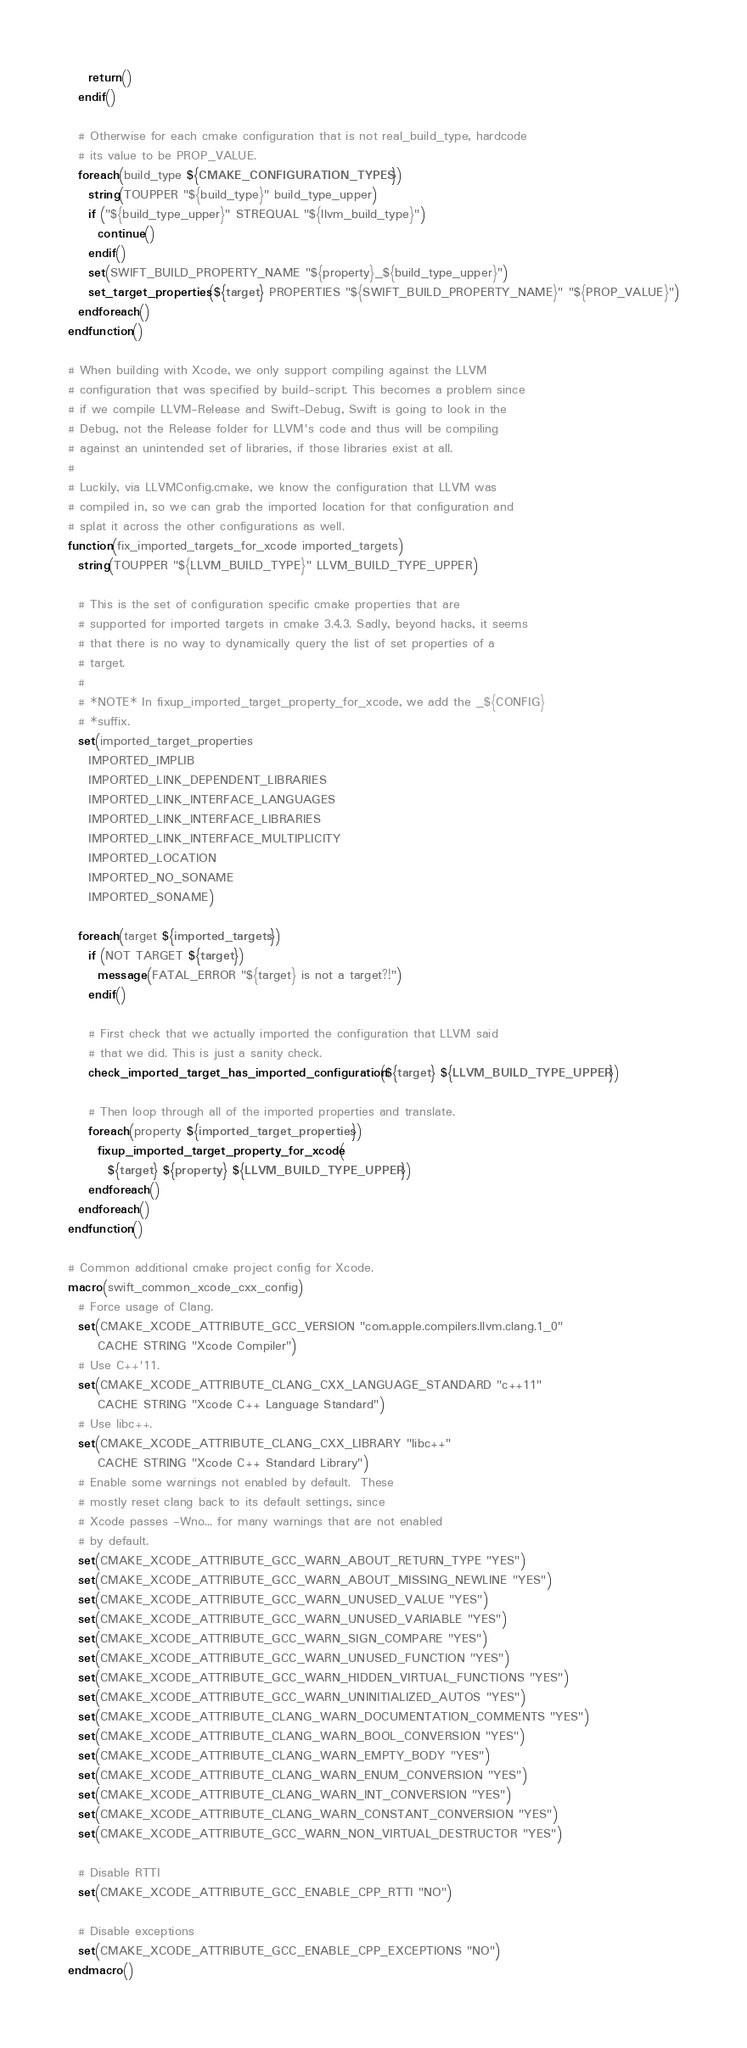Convert code to text. <code><loc_0><loc_0><loc_500><loc_500><_CMake_>    return()
  endif()

  # Otherwise for each cmake configuration that is not real_build_type, hardcode
  # its value to be PROP_VALUE.
  foreach(build_type ${CMAKE_CONFIGURATION_TYPES})
    string(TOUPPER "${build_type}" build_type_upper)
    if ("${build_type_upper}" STREQUAL "${llvm_build_type}")
      continue()
    endif()
    set(SWIFT_BUILD_PROPERTY_NAME "${property}_${build_type_upper}")
    set_target_properties(${target} PROPERTIES "${SWIFT_BUILD_PROPERTY_NAME}" "${PROP_VALUE}")
  endforeach()
endfunction()

# When building with Xcode, we only support compiling against the LLVM
# configuration that was specified by build-script. This becomes a problem since
# if we compile LLVM-Release and Swift-Debug, Swift is going to look in the
# Debug, not the Release folder for LLVM's code and thus will be compiling
# against an unintended set of libraries, if those libraries exist at all.
#
# Luckily, via LLVMConfig.cmake, we know the configuration that LLVM was
# compiled in, so we can grab the imported location for that configuration and
# splat it across the other configurations as well.
function(fix_imported_targets_for_xcode imported_targets)
  string(TOUPPER "${LLVM_BUILD_TYPE}" LLVM_BUILD_TYPE_UPPER)

  # This is the set of configuration specific cmake properties that are
  # supported for imported targets in cmake 3.4.3. Sadly, beyond hacks, it seems
  # that there is no way to dynamically query the list of set properties of a
  # target.
  #
  # *NOTE* In fixup_imported_target_property_for_xcode, we add the _${CONFIG}
  # *suffix.
  set(imported_target_properties
    IMPORTED_IMPLIB
    IMPORTED_LINK_DEPENDENT_LIBRARIES
    IMPORTED_LINK_INTERFACE_LANGUAGES
    IMPORTED_LINK_INTERFACE_LIBRARIES
    IMPORTED_LINK_INTERFACE_MULTIPLICITY
    IMPORTED_LOCATION
    IMPORTED_NO_SONAME
    IMPORTED_SONAME)

  foreach(target ${imported_targets})
    if (NOT TARGET ${target})
      message(FATAL_ERROR "${target} is not a target?!")
    endif()

    # First check that we actually imported the configuration that LLVM said
    # that we did. This is just a sanity check.
    check_imported_target_has_imported_configuration(${target} ${LLVM_BUILD_TYPE_UPPER})

    # Then loop through all of the imported properties and translate.
    foreach(property ${imported_target_properties})
      fixup_imported_target_property_for_xcode(
        ${target} ${property} ${LLVM_BUILD_TYPE_UPPER})
    endforeach()
  endforeach()
endfunction()

# Common additional cmake project config for Xcode.
macro(swift_common_xcode_cxx_config)
  # Force usage of Clang.
  set(CMAKE_XCODE_ATTRIBUTE_GCC_VERSION "com.apple.compilers.llvm.clang.1_0"
      CACHE STRING "Xcode Compiler")
  # Use C++'11.
  set(CMAKE_XCODE_ATTRIBUTE_CLANG_CXX_LANGUAGE_STANDARD "c++11"
      CACHE STRING "Xcode C++ Language Standard")
  # Use libc++.
  set(CMAKE_XCODE_ATTRIBUTE_CLANG_CXX_LIBRARY "libc++"
      CACHE STRING "Xcode C++ Standard Library")
  # Enable some warnings not enabled by default.  These
  # mostly reset clang back to its default settings, since
  # Xcode passes -Wno... for many warnings that are not enabled
  # by default.
  set(CMAKE_XCODE_ATTRIBUTE_GCC_WARN_ABOUT_RETURN_TYPE "YES")
  set(CMAKE_XCODE_ATTRIBUTE_GCC_WARN_ABOUT_MISSING_NEWLINE "YES")
  set(CMAKE_XCODE_ATTRIBUTE_GCC_WARN_UNUSED_VALUE "YES")
  set(CMAKE_XCODE_ATTRIBUTE_GCC_WARN_UNUSED_VARIABLE "YES")
  set(CMAKE_XCODE_ATTRIBUTE_GCC_WARN_SIGN_COMPARE "YES")
  set(CMAKE_XCODE_ATTRIBUTE_GCC_WARN_UNUSED_FUNCTION "YES")
  set(CMAKE_XCODE_ATTRIBUTE_GCC_WARN_HIDDEN_VIRTUAL_FUNCTIONS "YES")
  set(CMAKE_XCODE_ATTRIBUTE_GCC_WARN_UNINITIALIZED_AUTOS "YES")
  set(CMAKE_XCODE_ATTRIBUTE_CLANG_WARN_DOCUMENTATION_COMMENTS "YES")
  set(CMAKE_XCODE_ATTRIBUTE_CLANG_WARN_BOOL_CONVERSION "YES")
  set(CMAKE_XCODE_ATTRIBUTE_CLANG_WARN_EMPTY_BODY "YES")
  set(CMAKE_XCODE_ATTRIBUTE_CLANG_WARN_ENUM_CONVERSION "YES")
  set(CMAKE_XCODE_ATTRIBUTE_CLANG_WARN_INT_CONVERSION "YES")
  set(CMAKE_XCODE_ATTRIBUTE_CLANG_WARN_CONSTANT_CONVERSION "YES")
  set(CMAKE_XCODE_ATTRIBUTE_GCC_WARN_NON_VIRTUAL_DESTRUCTOR "YES")

  # Disable RTTI
  set(CMAKE_XCODE_ATTRIBUTE_GCC_ENABLE_CPP_RTTI "NO")

  # Disable exceptions
  set(CMAKE_XCODE_ATTRIBUTE_GCC_ENABLE_CPP_EXCEPTIONS "NO")
endmacro()
</code> 